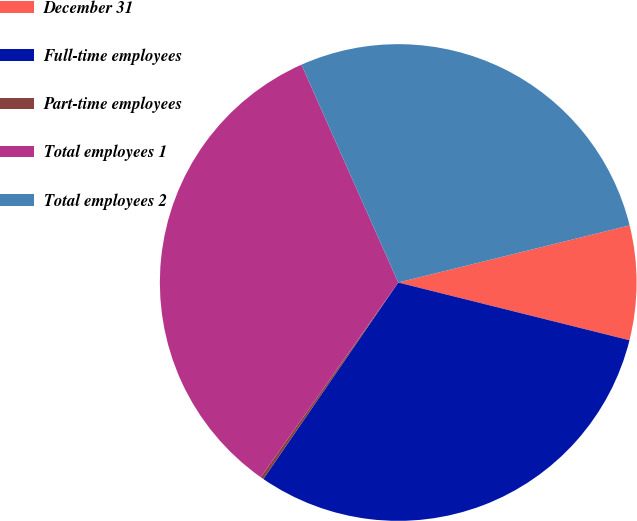<chart> <loc_0><loc_0><loc_500><loc_500><pie_chart><fcel>December 31<fcel>Full-time employees<fcel>Part-time employees<fcel>Total employees 1<fcel>Total employees 2<nl><fcel>7.75%<fcel>30.68%<fcel>0.21%<fcel>33.56%<fcel>27.8%<nl></chart> 